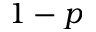<formula> <loc_0><loc_0><loc_500><loc_500>1 - p</formula> 